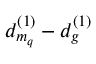<formula> <loc_0><loc_0><loc_500><loc_500>d _ { m _ { q } } ^ { ( 1 ) } - d _ { g } ^ { ( 1 ) }</formula> 